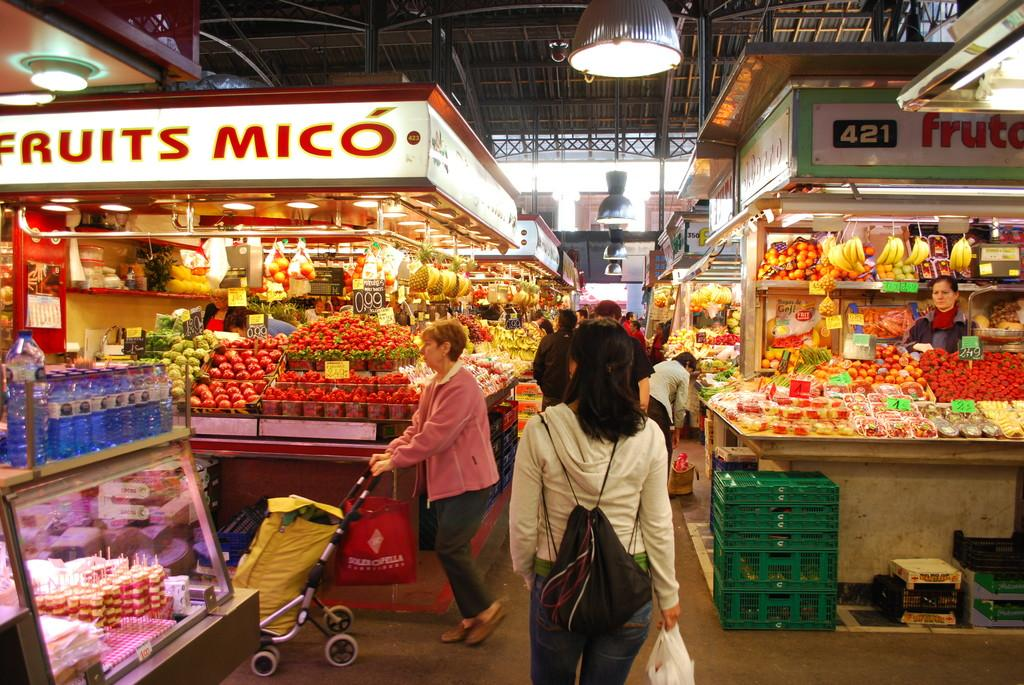<image>
Write a terse but informative summary of the picture. the inside of a fruit market with stalls reading Fruits Mico 